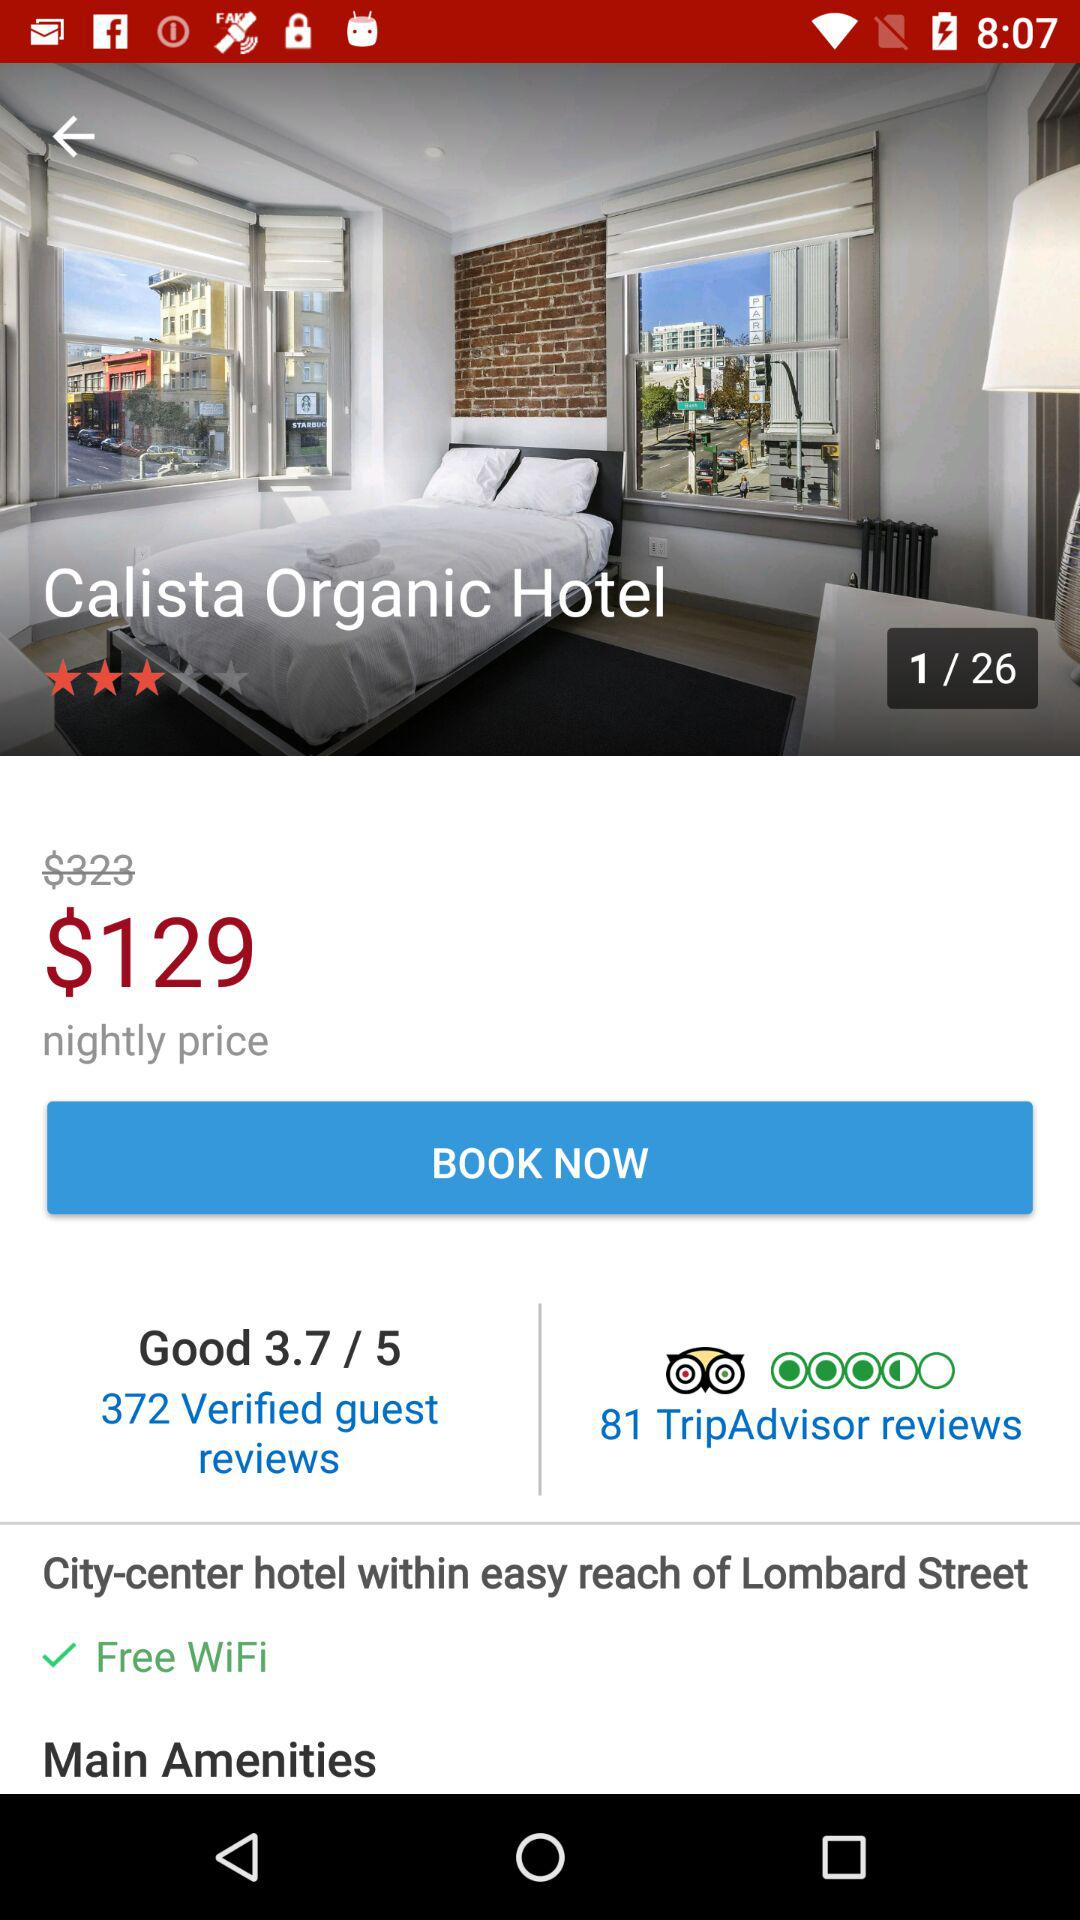How much cheaper is the hotel than the nightly price?
Answer the question using a single word or phrase. $194 